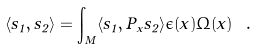<formula> <loc_0><loc_0><loc_500><loc_500>\langle s _ { 1 } , s _ { 2 } \rangle = \int _ { M } \langle s _ { 1 } , P _ { x } s _ { 2 } \rangle \epsilon ( x ) \Omega ( x ) \ .</formula> 